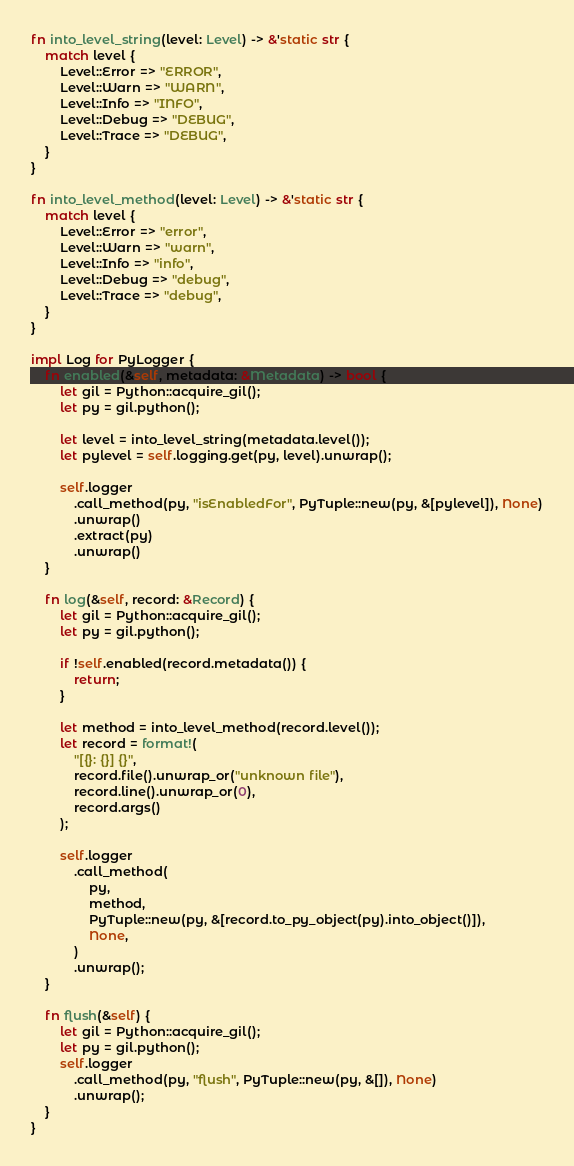<code> <loc_0><loc_0><loc_500><loc_500><_Rust_>fn into_level_string(level: Level) -> &'static str {
    match level {
        Level::Error => "ERROR",
        Level::Warn => "WARN",
        Level::Info => "INFO",
        Level::Debug => "DEBUG",
        Level::Trace => "DEBUG",
    }
}

fn into_level_method(level: Level) -> &'static str {
    match level {
        Level::Error => "error",
        Level::Warn => "warn",
        Level::Info => "info",
        Level::Debug => "debug",
        Level::Trace => "debug",
    }
}

impl Log for PyLogger {
    fn enabled(&self, metadata: &Metadata) -> bool {
        let gil = Python::acquire_gil();
        let py = gil.python();

        let level = into_level_string(metadata.level());
        let pylevel = self.logging.get(py, level).unwrap();

        self.logger
            .call_method(py, "isEnabledFor", PyTuple::new(py, &[pylevel]), None)
            .unwrap()
            .extract(py)
            .unwrap()
    }

    fn log(&self, record: &Record) {
        let gil = Python::acquire_gil();
        let py = gil.python();

        if !self.enabled(record.metadata()) {
            return;
        }

        let method = into_level_method(record.level());
        let record = format!(
            "[{}: {}] {}",
            record.file().unwrap_or("unknown file"),
            record.line().unwrap_or(0),
            record.args()
        );

        self.logger
            .call_method(
                py,
                method,
                PyTuple::new(py, &[record.to_py_object(py).into_object()]),
                None,
            )
            .unwrap();
    }

    fn flush(&self) {
        let gil = Python::acquire_gil();
        let py = gil.python();
        self.logger
            .call_method(py, "flush", PyTuple::new(py, &[]), None)
            .unwrap();
    }
}
</code> 